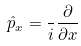<formula> <loc_0><loc_0><loc_500><loc_500>\hat { p } _ { x } = \frac { } { i } \frac { \partial } { \partial x }</formula> 